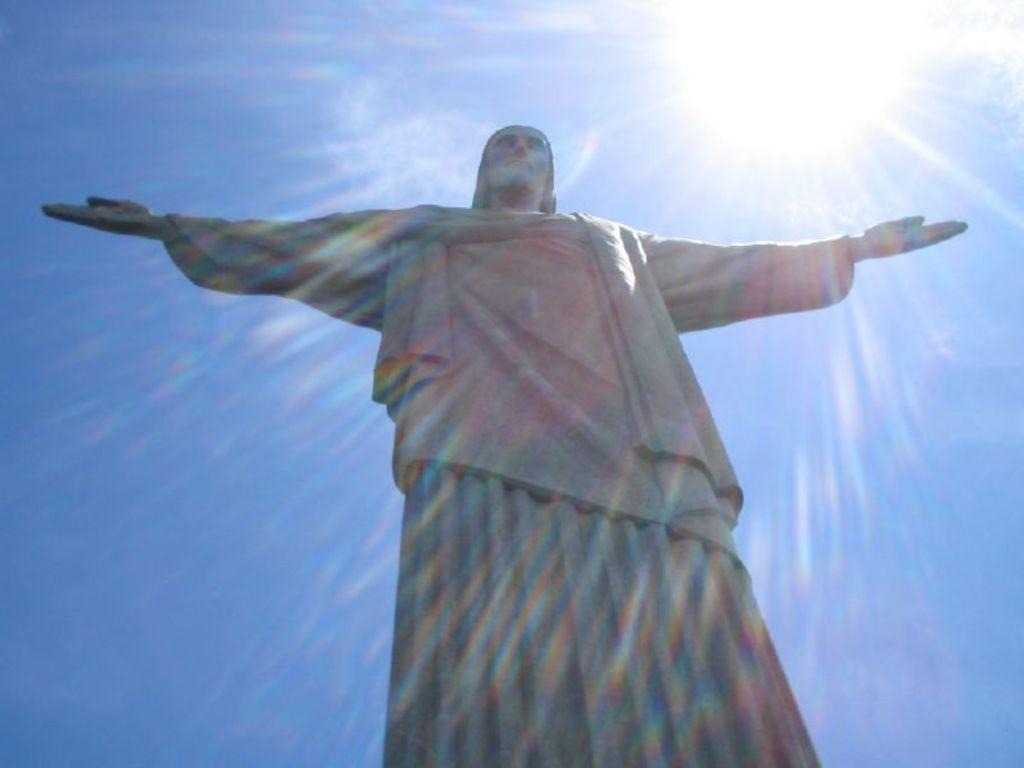What is the main subject of the image? There is a huge statue in the image. What is the statue shaped like? The statue is in the shape of a person. What can be seen in the background of the image? The sky is visible in the background of the image. Can the sun be seen in the image? Yes, the sun is observable in the sky. What year is the statue discussing in the image? There is no discussion taking place in the image, and therefore no year can be associated with it. Additionally, statues do not engage in discussions. How many snails are crawling on the statue in the image? There are no snails present in the image; the statue is the main subject. 